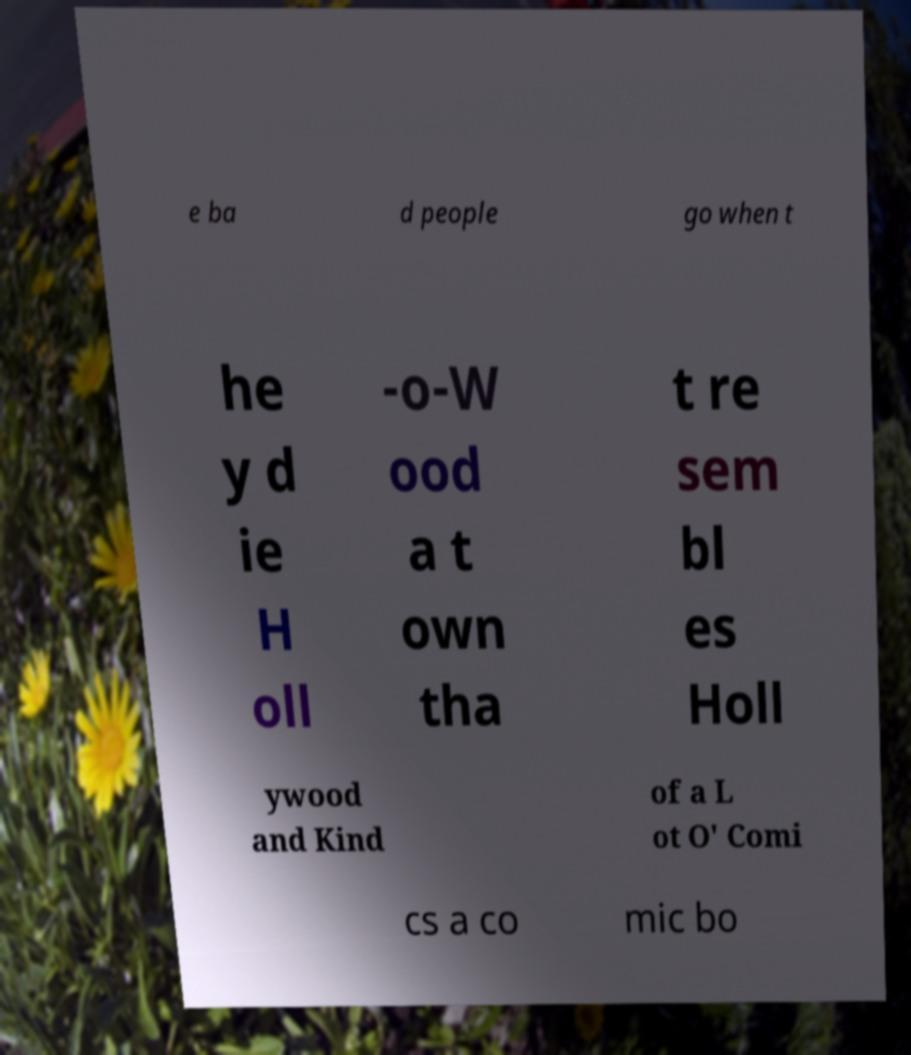Can you read and provide the text displayed in the image?This photo seems to have some interesting text. Can you extract and type it out for me? e ba d people go when t he y d ie H oll -o-W ood a t own tha t re sem bl es Holl ywood and Kind of a L ot O' Comi cs a co mic bo 